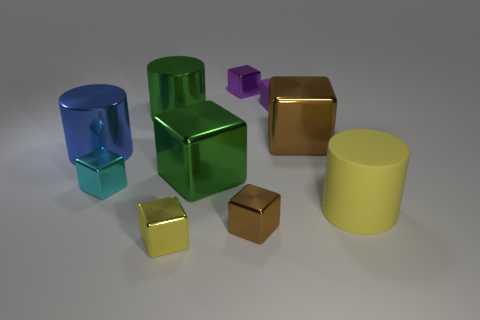What materials do the objects in the image appear to be made of? The objects in the image appear to have surfaces that resemble common materials found in computer renderings. For instance, the shiny surfaces suggest metallic or reflective plastic materials, lending each object a distinct visual texture that could imply a range of substances from polished metal to smooth plastic. 